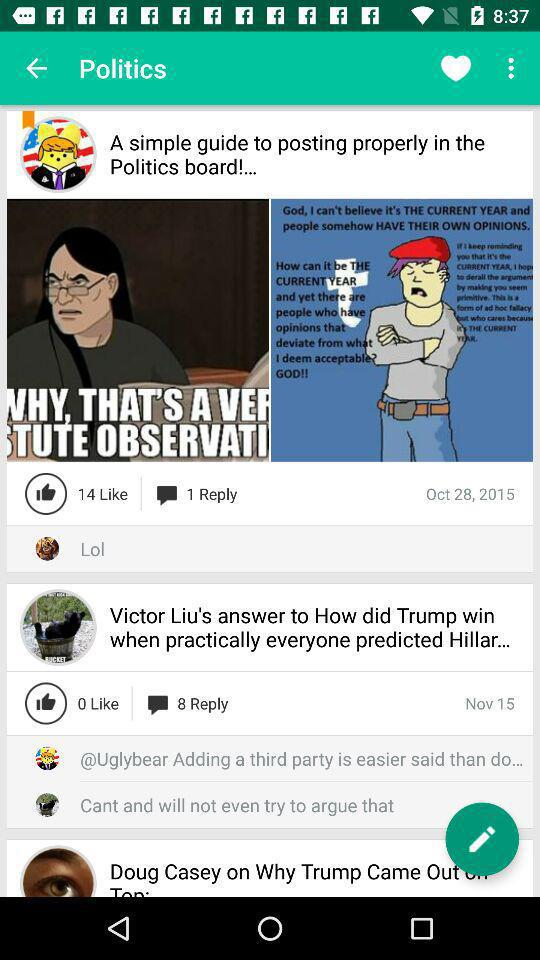When was the post "A simple guide to posting properly in the Politics board!..." posted? The post was posted on October 28, 2015. 